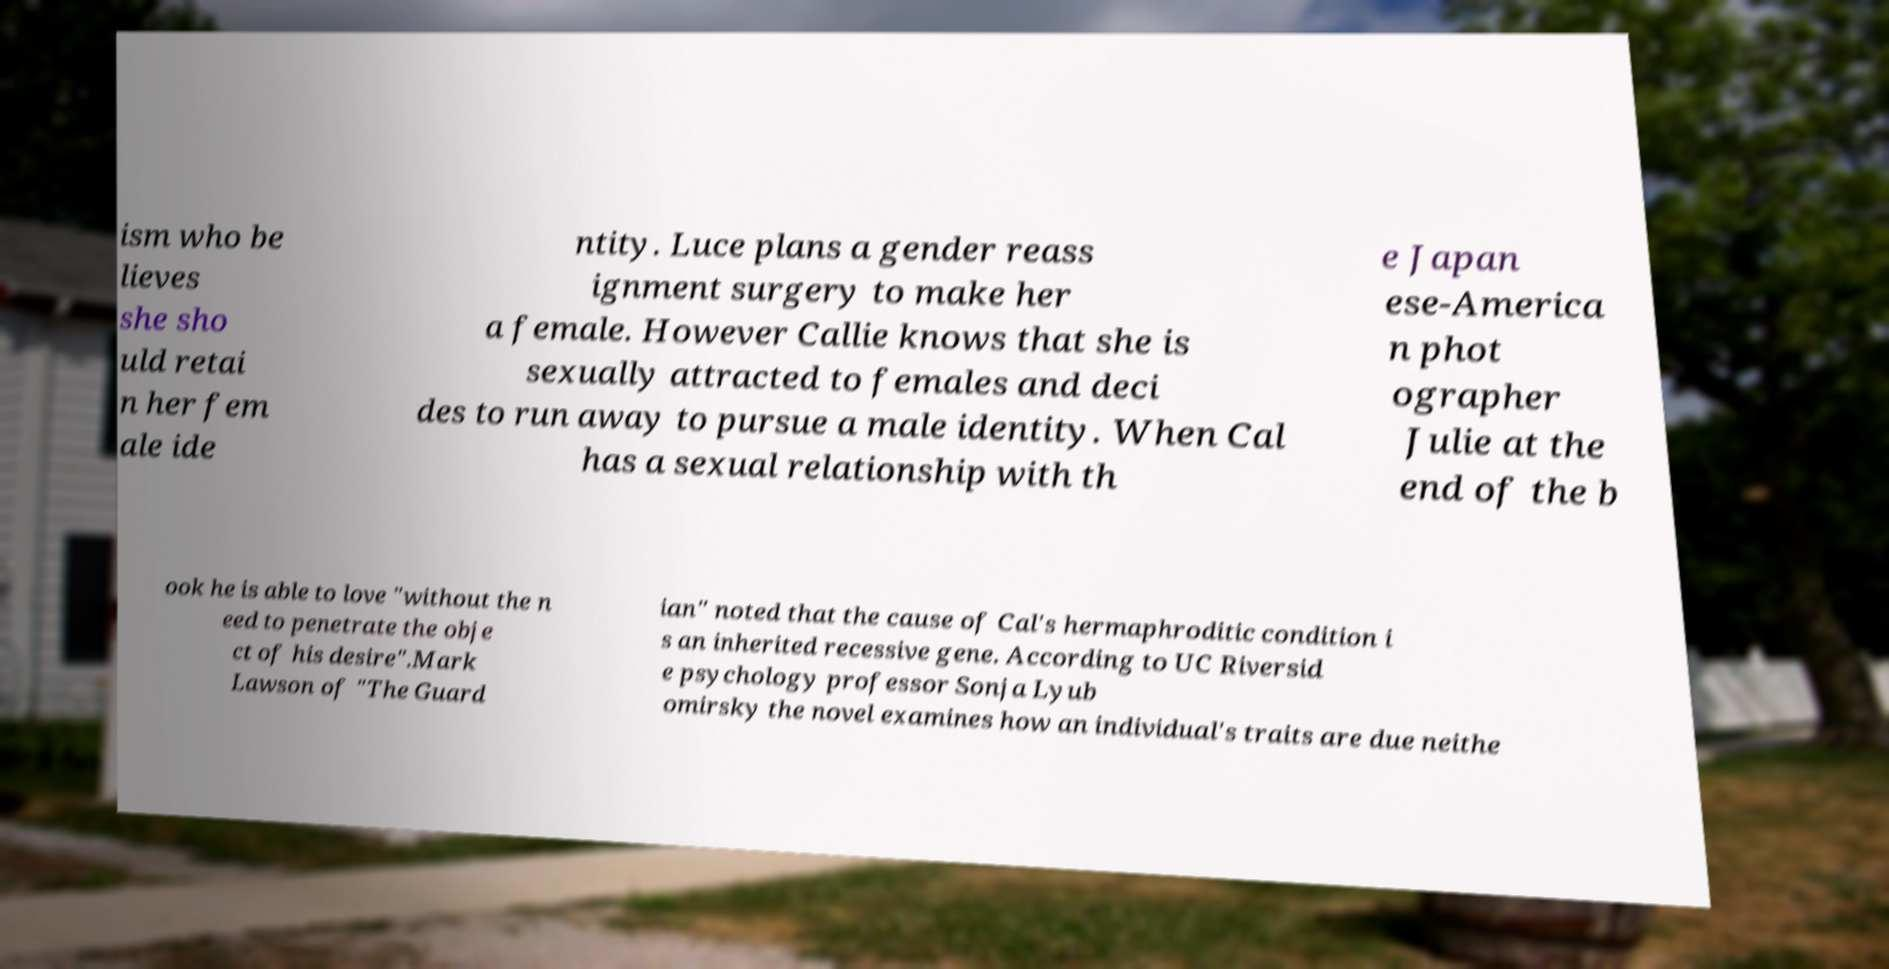Please identify and transcribe the text found in this image. ism who be lieves she sho uld retai n her fem ale ide ntity. Luce plans a gender reass ignment surgery to make her a female. However Callie knows that she is sexually attracted to females and deci des to run away to pursue a male identity. When Cal has a sexual relationship with th e Japan ese-America n phot ographer Julie at the end of the b ook he is able to love "without the n eed to penetrate the obje ct of his desire".Mark Lawson of "The Guard ian" noted that the cause of Cal's hermaphroditic condition i s an inherited recessive gene. According to UC Riversid e psychology professor Sonja Lyub omirsky the novel examines how an individual's traits are due neithe 